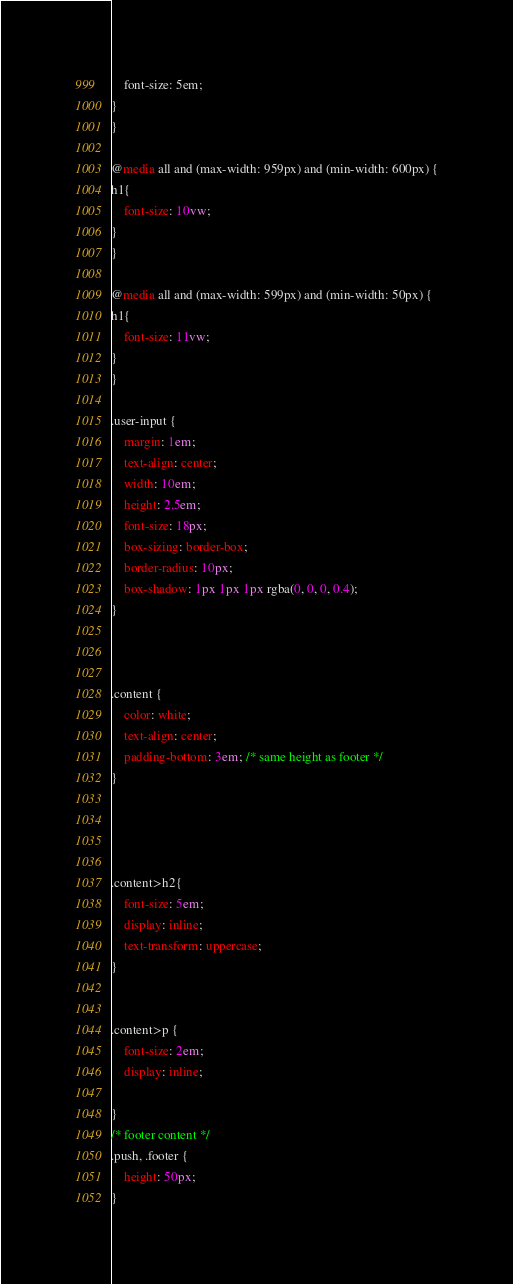<code> <loc_0><loc_0><loc_500><loc_500><_CSS_>	font-size: 5em;
}		 
}

@media all and (max-width: 959px) and (min-width: 600px) {
h1{
	font-size: 10vw;
}
}

@media all and (max-width: 599px) and (min-width: 50px) {
h1{
	font-size: 11vw;
}
}

.user-input {
    margin: 1em;
	text-align: center;
    width: 10em;
    height: 2.5em;
    font-size: 18px;
    box-sizing: border-box;
    border-radius: 10px;
    box-shadow: 1px 1px 1px rgba(0, 0, 0, 0.4);
}



.content {
    color: white;
    text-align: center;
	padding-bottom: 3em; /* same height as footer */
}




.content>h2{
    font-size: 5em;
    display: inline;
    text-transform: uppercase;
}


.content>p {
    font-size: 2em;
    display: inline;

}
/* footer content */
.push, .footer {
	height: 50px;
}</code> 